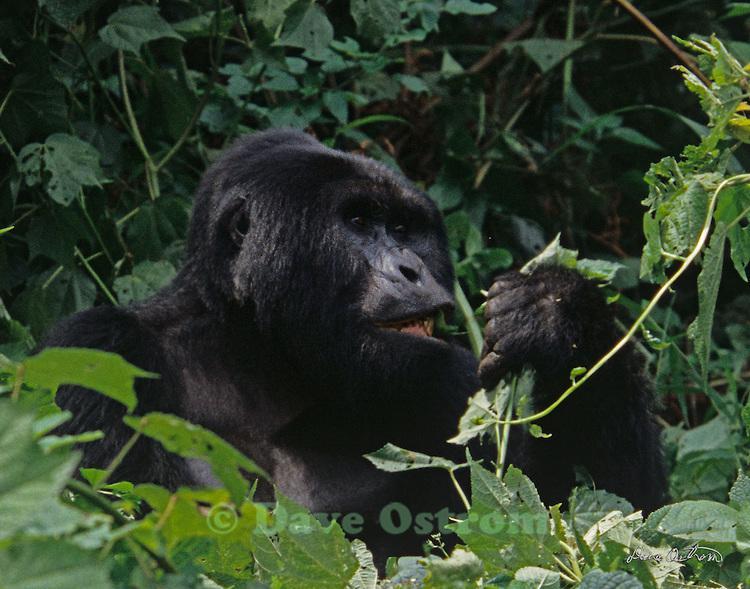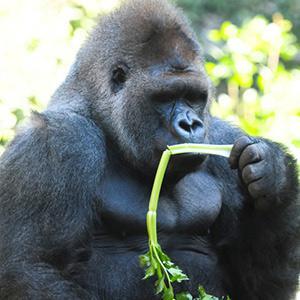The first image is the image on the left, the second image is the image on the right. Examine the images to the left and right. Is the description "All of the gorillas are holding food in their left hand." accurate? Answer yes or no. Yes. 